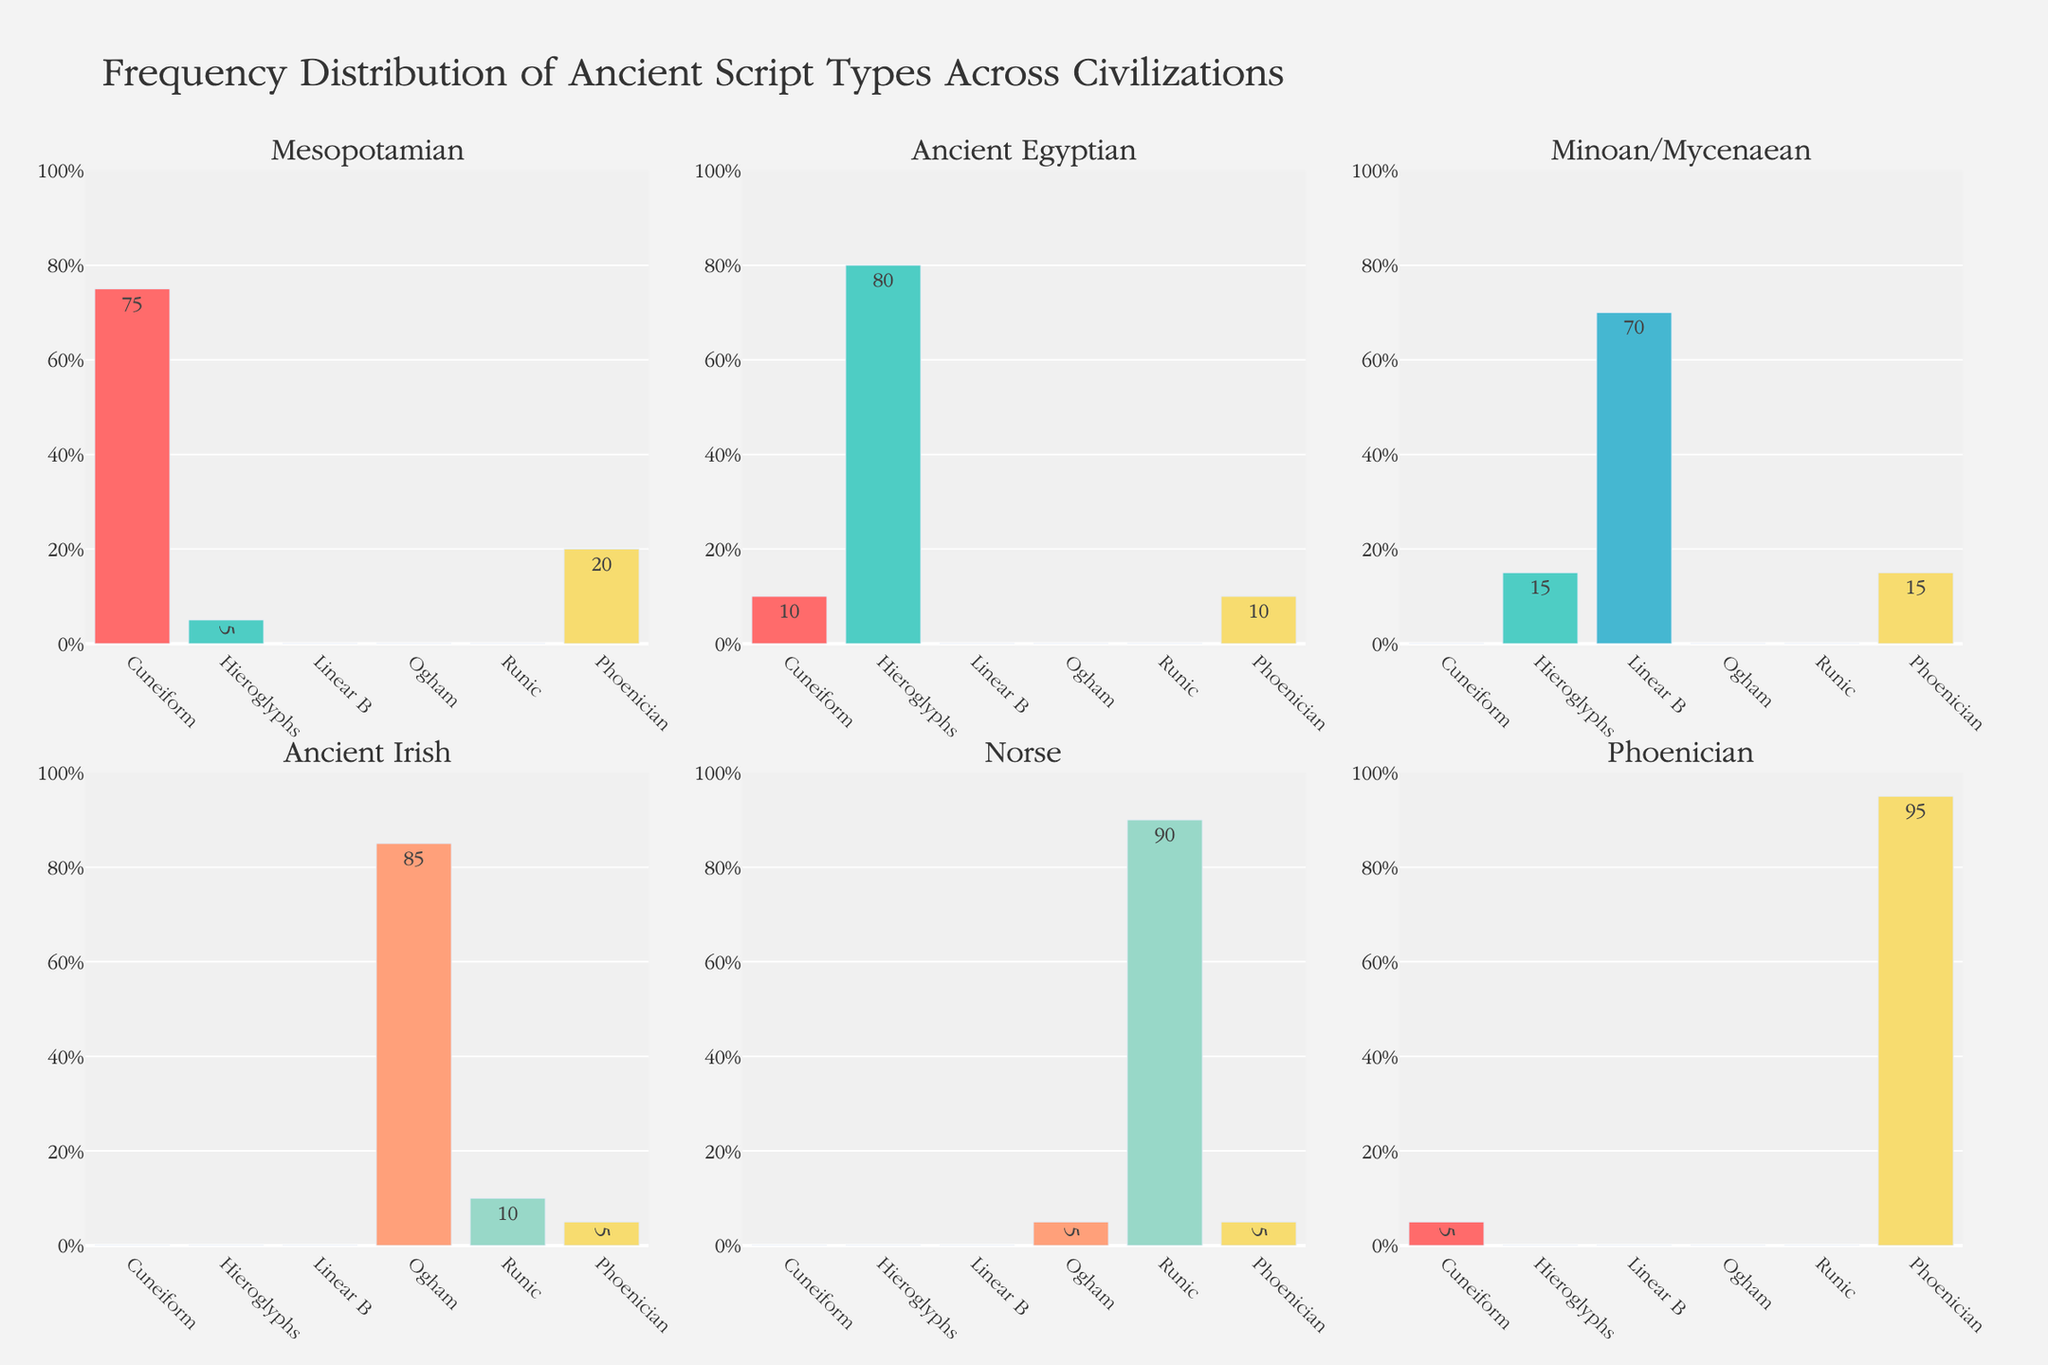Which civilization has the highest frequency of Phoenician script? To determine this, locate the bars representing the Phoenician script (indicated in gold color) across each subplot. Identify the tallest bar among these.
Answer: Phoenician Which script type is least represented in the Mesopotamian civilization? In the subplot labeled "Mesopotamian," observe the shortest bar which indicates the lowest frequency.
Answer: Linear B, Ogham, Runic What’s the total frequency of all script types in the Norse civilization? Sum the values of all script types in the subplot labeled "Norse" (0 + 0 + 0 + 5 + 90 + 5).
Answer: 100% Which civilization shows a higher frequency of Ogham script: Ancient Irish or Norse? Compare the heights of the bars representing Ogham script in the subplots labeled "Ancient Irish" and "Norse."
Answer: Ancient Irish How does the frequency of Hieroglyphs in the Minoan/Mycenaean civilization compare to that in the Ancient Egyptian civilization? Look at the bars representing Hieroglyphs in the "Minoan/Mycenaean" and "Ancient Egyptian" subplots. Compare these two values.
Answer: Lower in Minoan/Mycenaean What is the average frequency of Cuneiform script across all civilizations? Sum the frequencies of Cuneiform script across all civilizations (75 + 10 + 0 + 0 + 0 + 5) and divide by the number of civilizations.
Answer: 15% Which script type has the highest variation in frequency across all civilizations? Compare the frequency values of each script type across all civilizations and identify which has the widest range of numbers.
Answer: Cuneiform Is there any civilization that uses both Linear B and Runic scripts? Check each subplot to see if there's a civilization with non-zero bars for both Linear B and Runic scripts.
Answer: No In which civilization are Cuneiform and Hieroglyphs almost equally represented? Look for a civilization where the heights of bars for Cuneiform and Hieroglyphs are nearly the same.
Answer: Minoan/Mycenaean 